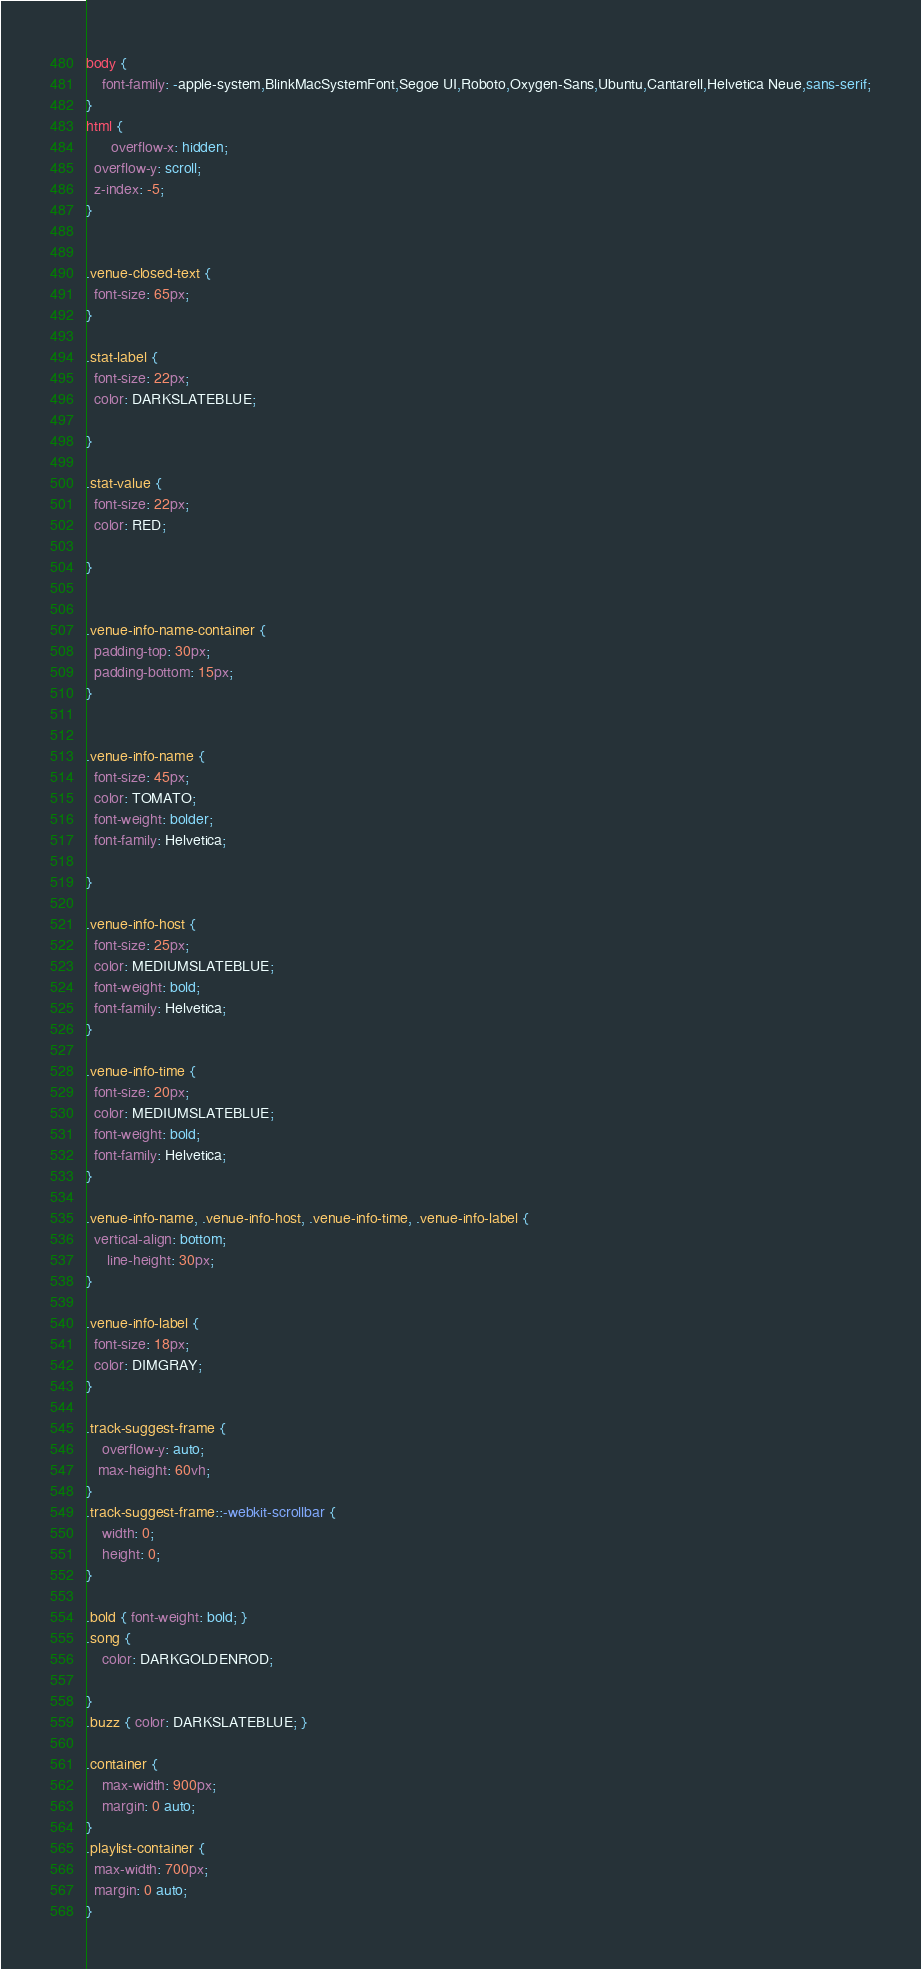Convert code to text. <code><loc_0><loc_0><loc_500><loc_500><_CSS_>body {
    font-family: -apple-system,BlinkMacSystemFont,Segoe UI,Roboto,Oxygen-Sans,Ubuntu,Cantarell,Helvetica Neue,sans-serif;
}
html {
      overflow-x: hidden;
  overflow-y: scroll;
  z-index: -5;
}


.venue-closed-text {
  font-size: 65px;
}

.stat-label {
  font-size: 22px;
  color: DARKSLATEBLUE;

}

.stat-value {
  font-size: 22px;
  color: RED;

}


.venue-info-name-container {
  padding-top: 30px;
  padding-bottom: 15px;
}


.venue-info-name {
  font-size: 45px;
  color: TOMATO;
  font-weight: bolder;
  font-family: Helvetica;

}

.venue-info-host {
  font-size: 25px;
  color: MEDIUMSLATEBLUE;
  font-weight: bold;
  font-family: Helvetica;
}

.venue-info-time {
  font-size: 20px;
  color: MEDIUMSLATEBLUE;
  font-weight: bold;
  font-family: Helvetica;
}

.venue-info-name, .venue-info-host, .venue-info-time, .venue-info-label {
  vertical-align: bottom;
     line-height: 30px;
}

.venue-info-label {
  font-size: 18px;
  color: DIMGRAY;
}

.track-suggest-frame {
    overflow-y: auto;
   max-height: 60vh;
}
.track-suggest-frame::-webkit-scrollbar {
    width: 0;
    height: 0;
}

.bold { font-weight: bold; }
.song { 
	color: DARKGOLDENROD; 

}
.buzz { color: DARKSLATEBLUE; }

.container {
	max-width: 900px;
	margin: 0 auto;
}
.playlist-container {
  max-width: 700px;
  margin: 0 auto;
}
</code> 